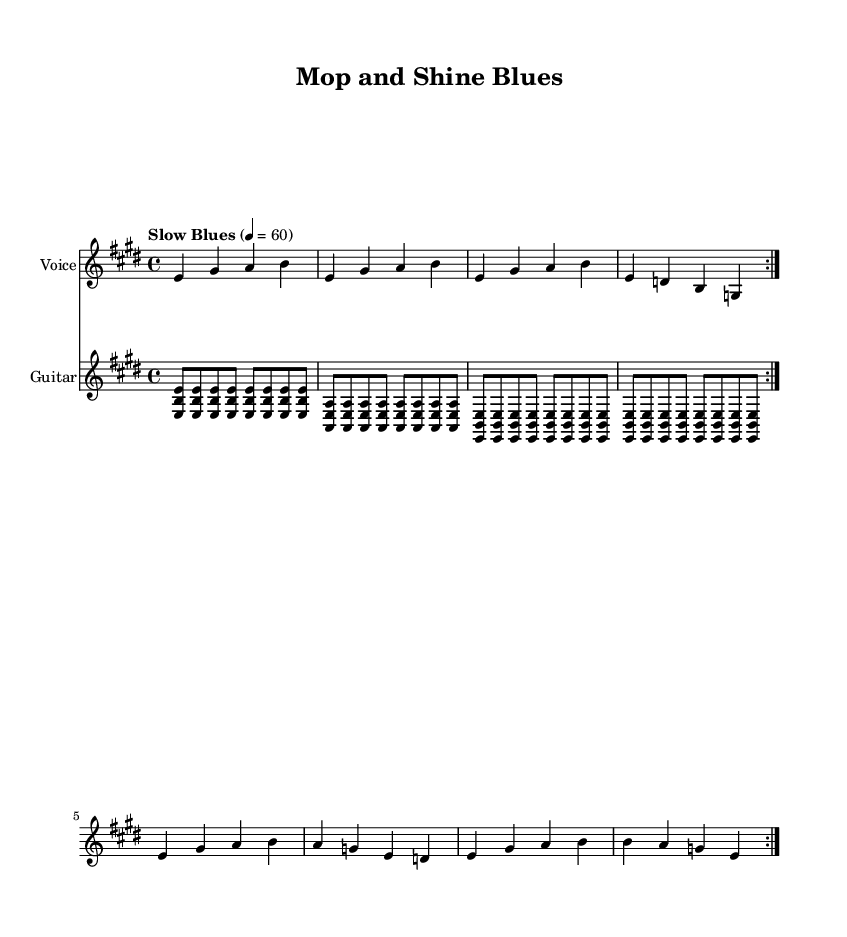What is the tempo marking of this music? The tempo marking indicates "Slow Blues" with a metronome marking of 60 beats per minute. This suggests that the piece should be played at a relaxed and leisurely pace.
Answer: Slow Blues, 60 What is the time signature of this music? The time signature is indicated at the beginning of the score as 4/4, which means there are four beats in each measure and the quarter note gets one beat.
Answer: 4/4 What is the key signature of this music? The key signature shows two sharps (F# and C#), indicating that this piece is in the key of E major. This can be seen at the start of the staff lines.
Answer: E major How many times does the main melody repeat? The main melody is indicated by the repeat sign "volta" which shows that it is played two times. The notation specifically states \repeat volta 2, which directs the performer to repeat that section twice.
Answer: 2 What instruments are used in this music? The score specifies that there are two instruments: Voice and Guitar. This is noted with the instrument name above each staff in the score.
Answer: Voice, Guitar What lyrical themes are explored in this blues piece? The lyrics convey themes of personal growth and skill development related to blue-collar work. Phrases like "learning from the best" and "climbing up that ladder" suggest an emphasis on learning and aspiring toward goals.
Answer: Personal growth, skill development What typical structure does this blues music follow? The piece follows a standard blues structure characterized by a twelve-bar form, which is typical in blues music. This can be inferred from the repetitive chord patterns and lyrical phrasing.
Answer: Twelve-bar form 